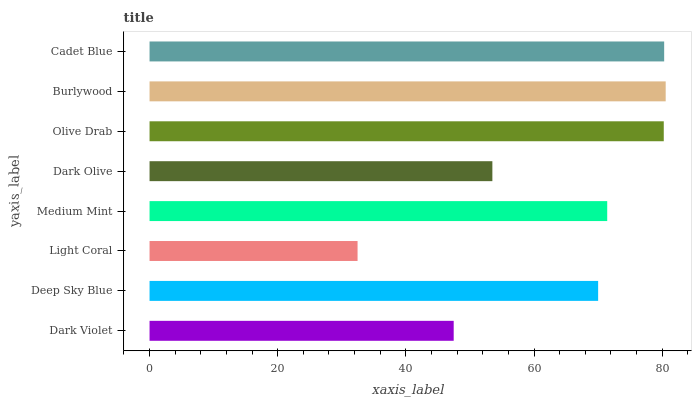Is Light Coral the minimum?
Answer yes or no. Yes. Is Burlywood the maximum?
Answer yes or no. Yes. Is Deep Sky Blue the minimum?
Answer yes or no. No. Is Deep Sky Blue the maximum?
Answer yes or no. No. Is Deep Sky Blue greater than Dark Violet?
Answer yes or no. Yes. Is Dark Violet less than Deep Sky Blue?
Answer yes or no. Yes. Is Dark Violet greater than Deep Sky Blue?
Answer yes or no. No. Is Deep Sky Blue less than Dark Violet?
Answer yes or no. No. Is Medium Mint the high median?
Answer yes or no. Yes. Is Deep Sky Blue the low median?
Answer yes or no. Yes. Is Dark Violet the high median?
Answer yes or no. No. Is Medium Mint the low median?
Answer yes or no. No. 